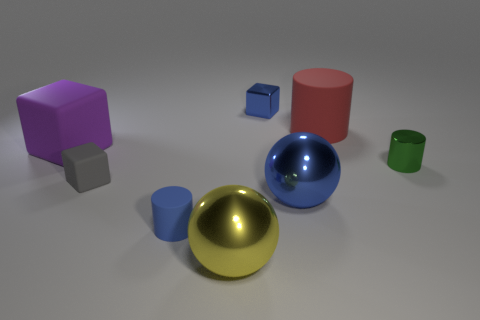Which two objects seem to share the same color but different shapes? The two objects that share a similar shade of blue while differing in shape are the small cube and the larger cylinder. 